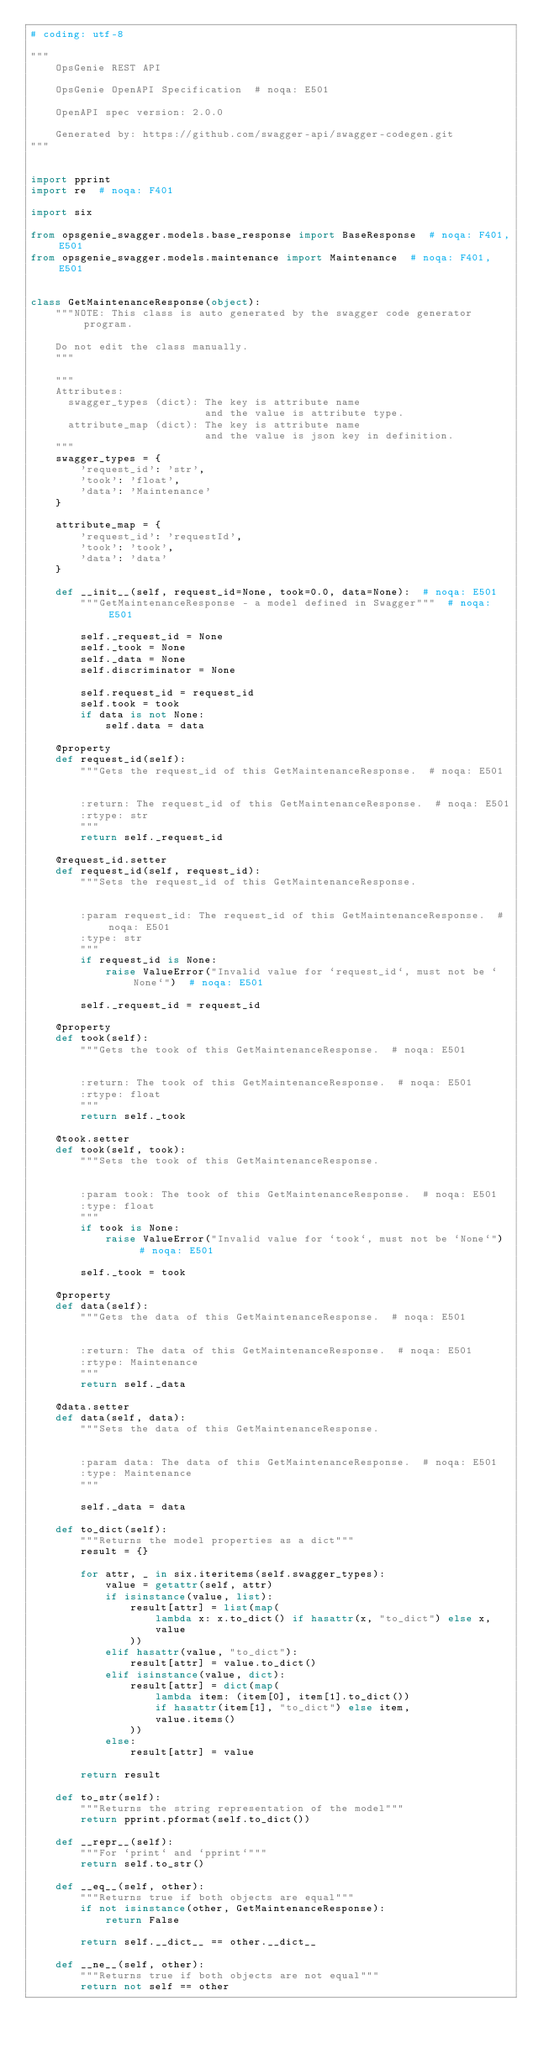<code> <loc_0><loc_0><loc_500><loc_500><_Python_># coding: utf-8

"""
    OpsGenie REST API

    OpsGenie OpenAPI Specification  # noqa: E501

    OpenAPI spec version: 2.0.0
    
    Generated by: https://github.com/swagger-api/swagger-codegen.git
"""


import pprint
import re  # noqa: F401

import six

from opsgenie_swagger.models.base_response import BaseResponse  # noqa: F401,E501
from opsgenie_swagger.models.maintenance import Maintenance  # noqa: F401,E501


class GetMaintenanceResponse(object):
    """NOTE: This class is auto generated by the swagger code generator program.

    Do not edit the class manually.
    """

    """
    Attributes:
      swagger_types (dict): The key is attribute name
                            and the value is attribute type.
      attribute_map (dict): The key is attribute name
                            and the value is json key in definition.
    """
    swagger_types = {
        'request_id': 'str',
        'took': 'float',
        'data': 'Maintenance'
    }

    attribute_map = {
        'request_id': 'requestId',
        'took': 'took',
        'data': 'data'
    }

    def __init__(self, request_id=None, took=0.0, data=None):  # noqa: E501
        """GetMaintenanceResponse - a model defined in Swagger"""  # noqa: E501

        self._request_id = None
        self._took = None
        self._data = None
        self.discriminator = None

        self.request_id = request_id
        self.took = took
        if data is not None:
            self.data = data

    @property
    def request_id(self):
        """Gets the request_id of this GetMaintenanceResponse.  # noqa: E501


        :return: The request_id of this GetMaintenanceResponse.  # noqa: E501
        :rtype: str
        """
        return self._request_id

    @request_id.setter
    def request_id(self, request_id):
        """Sets the request_id of this GetMaintenanceResponse.


        :param request_id: The request_id of this GetMaintenanceResponse.  # noqa: E501
        :type: str
        """
        if request_id is None:
            raise ValueError("Invalid value for `request_id`, must not be `None`")  # noqa: E501

        self._request_id = request_id

    @property
    def took(self):
        """Gets the took of this GetMaintenanceResponse.  # noqa: E501


        :return: The took of this GetMaintenanceResponse.  # noqa: E501
        :rtype: float
        """
        return self._took

    @took.setter
    def took(self, took):
        """Sets the took of this GetMaintenanceResponse.


        :param took: The took of this GetMaintenanceResponse.  # noqa: E501
        :type: float
        """
        if took is None:
            raise ValueError("Invalid value for `took`, must not be `None`")  # noqa: E501

        self._took = took

    @property
    def data(self):
        """Gets the data of this GetMaintenanceResponse.  # noqa: E501


        :return: The data of this GetMaintenanceResponse.  # noqa: E501
        :rtype: Maintenance
        """
        return self._data

    @data.setter
    def data(self, data):
        """Sets the data of this GetMaintenanceResponse.


        :param data: The data of this GetMaintenanceResponse.  # noqa: E501
        :type: Maintenance
        """

        self._data = data

    def to_dict(self):
        """Returns the model properties as a dict"""
        result = {}

        for attr, _ in six.iteritems(self.swagger_types):
            value = getattr(self, attr)
            if isinstance(value, list):
                result[attr] = list(map(
                    lambda x: x.to_dict() if hasattr(x, "to_dict") else x,
                    value
                ))
            elif hasattr(value, "to_dict"):
                result[attr] = value.to_dict()
            elif isinstance(value, dict):
                result[attr] = dict(map(
                    lambda item: (item[0], item[1].to_dict())
                    if hasattr(item[1], "to_dict") else item,
                    value.items()
                ))
            else:
                result[attr] = value

        return result

    def to_str(self):
        """Returns the string representation of the model"""
        return pprint.pformat(self.to_dict())

    def __repr__(self):
        """For `print` and `pprint`"""
        return self.to_str()

    def __eq__(self, other):
        """Returns true if both objects are equal"""
        if not isinstance(other, GetMaintenanceResponse):
            return False

        return self.__dict__ == other.__dict__

    def __ne__(self, other):
        """Returns true if both objects are not equal"""
        return not self == other
</code> 